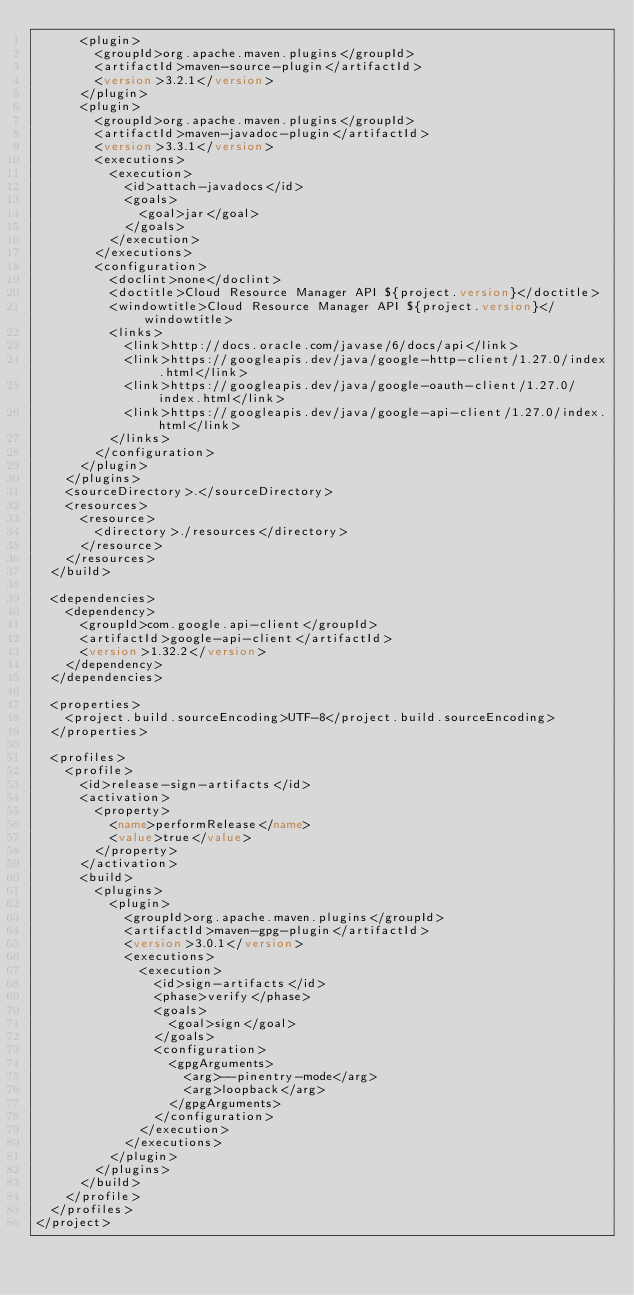Convert code to text. <code><loc_0><loc_0><loc_500><loc_500><_XML_>      <plugin>
        <groupId>org.apache.maven.plugins</groupId>
        <artifactId>maven-source-plugin</artifactId>
        <version>3.2.1</version>
      </plugin>
      <plugin>
        <groupId>org.apache.maven.plugins</groupId>
        <artifactId>maven-javadoc-plugin</artifactId>
        <version>3.3.1</version>
        <executions>
          <execution>
            <id>attach-javadocs</id>
            <goals>
              <goal>jar</goal>
            </goals>
          </execution>
        </executions>
        <configuration>
          <doclint>none</doclint>
          <doctitle>Cloud Resource Manager API ${project.version}</doctitle>
          <windowtitle>Cloud Resource Manager API ${project.version}</windowtitle>
          <links>
            <link>http://docs.oracle.com/javase/6/docs/api</link>
            <link>https://googleapis.dev/java/google-http-client/1.27.0/index.html</link>
            <link>https://googleapis.dev/java/google-oauth-client/1.27.0/index.html</link>
            <link>https://googleapis.dev/java/google-api-client/1.27.0/index.html</link>
          </links>
        </configuration>
      </plugin>
    </plugins>
    <sourceDirectory>.</sourceDirectory>
    <resources>
      <resource>
        <directory>./resources</directory>
      </resource>
    </resources>
  </build>

  <dependencies>
    <dependency>
      <groupId>com.google.api-client</groupId>
      <artifactId>google-api-client</artifactId>
      <version>1.32.2</version>
    </dependency>
  </dependencies>

  <properties>
    <project.build.sourceEncoding>UTF-8</project.build.sourceEncoding>
  </properties>

  <profiles>
    <profile>
      <id>release-sign-artifacts</id>
      <activation>
        <property>
          <name>performRelease</name>
          <value>true</value>
        </property>
      </activation>
      <build>
        <plugins>
          <plugin>
            <groupId>org.apache.maven.plugins</groupId>
            <artifactId>maven-gpg-plugin</artifactId>
            <version>3.0.1</version>
            <executions>
              <execution>
                <id>sign-artifacts</id>
                <phase>verify</phase>
                <goals>
                  <goal>sign</goal>
                </goals>
                <configuration>
                  <gpgArguments>
                    <arg>--pinentry-mode</arg>
                    <arg>loopback</arg>
                  </gpgArguments>
                </configuration>
              </execution>
            </executions>
          </plugin>
        </plugins>
      </build>
    </profile>
  </profiles>
</project></code> 